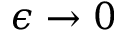Convert formula to latex. <formula><loc_0><loc_0><loc_500><loc_500>\epsilon \to 0</formula> 